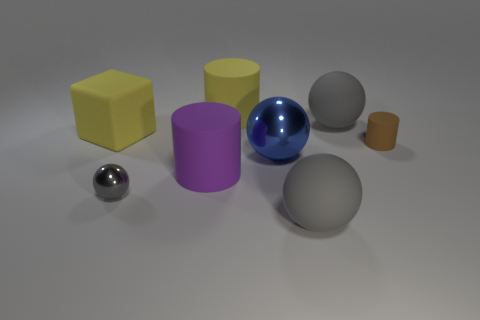What is the material of the big sphere that is behind the cylinder that is to the right of the large yellow rubber cylinder?
Keep it short and to the point. Rubber. Does the purple rubber object have the same shape as the tiny gray metal thing?
Keep it short and to the point. No. There is a metallic object that is the same size as the purple matte cylinder; what color is it?
Your response must be concise. Blue. Is there a shiny cylinder of the same color as the big cube?
Make the answer very short. No. Are there any gray objects?
Your answer should be very brief. Yes. Is the large gray sphere in front of the large metallic ball made of the same material as the yellow cylinder?
Offer a terse response. Yes. How many blue rubber cylinders have the same size as the purple cylinder?
Make the answer very short. 0. Are there an equal number of large blue balls behind the small metal ball and gray shiny spheres?
Keep it short and to the point. Yes. What number of things are both in front of the large metal thing and to the left of the large blue metallic thing?
Your response must be concise. 2. What size is the blue thing that is made of the same material as the tiny gray sphere?
Keep it short and to the point. Large. 